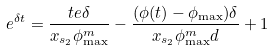Convert formula to latex. <formula><loc_0><loc_0><loc_500><loc_500>e ^ { \delta t } = \frac { t e \delta } { x _ { s _ { 2 } } \phi ^ { m } _ { \max } } - \frac { ( \phi ( t ) - \phi _ { \max } ) \delta } { x _ { s _ { 2 } } \phi ^ { m } _ { \max } d } + 1</formula> 